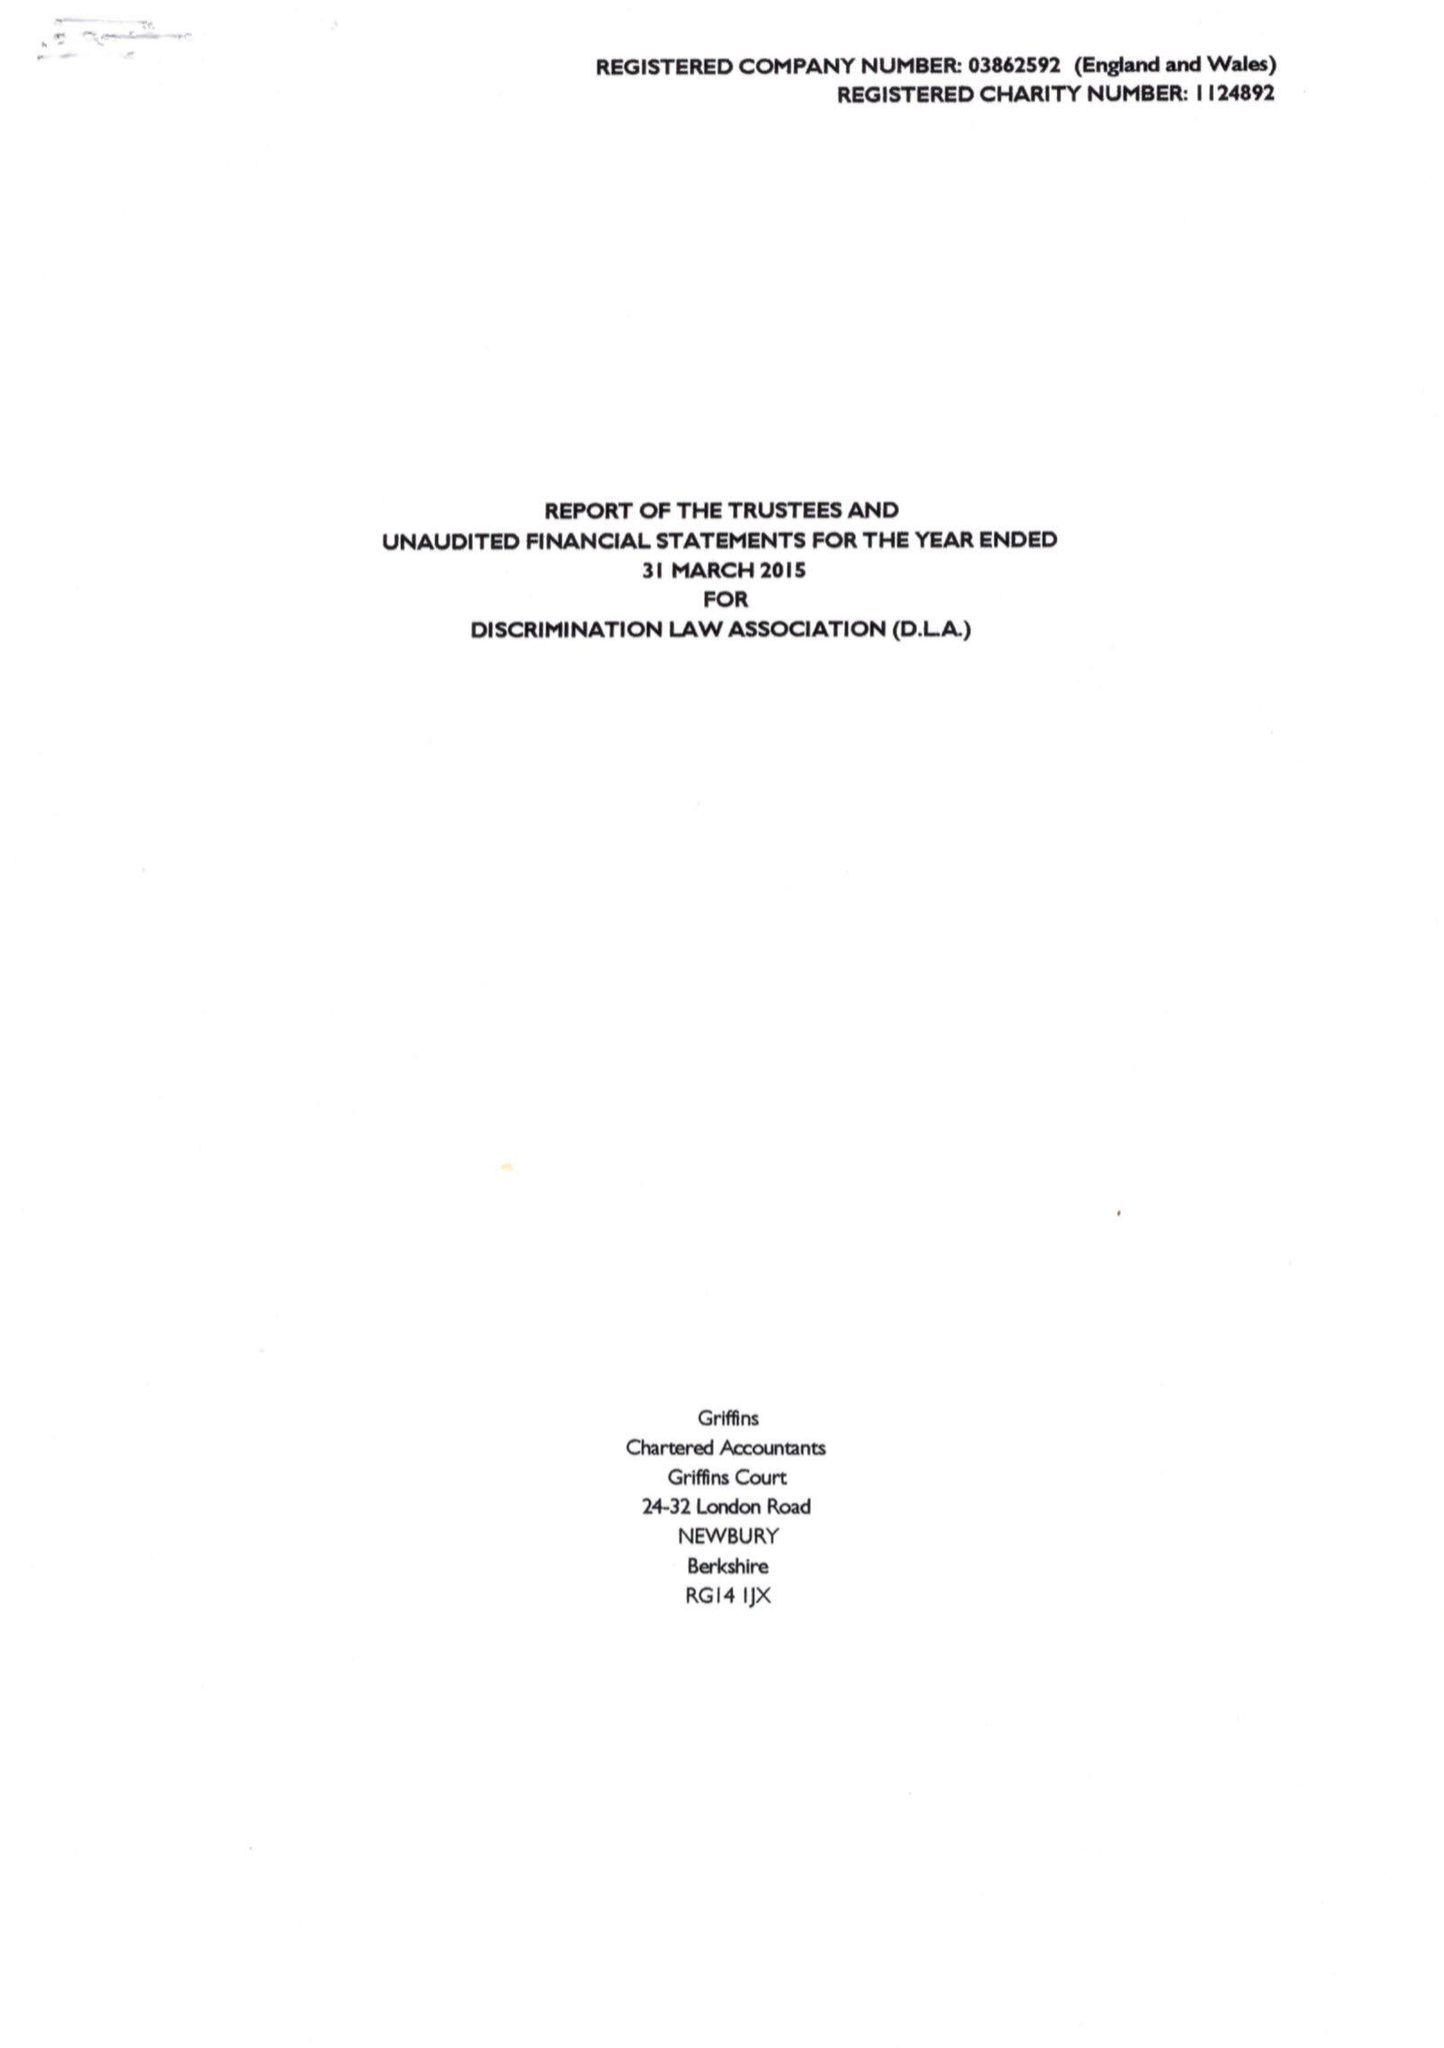What is the value for the income_annually_in_british_pounds?
Answer the question using a single word or phrase. 29312.00 